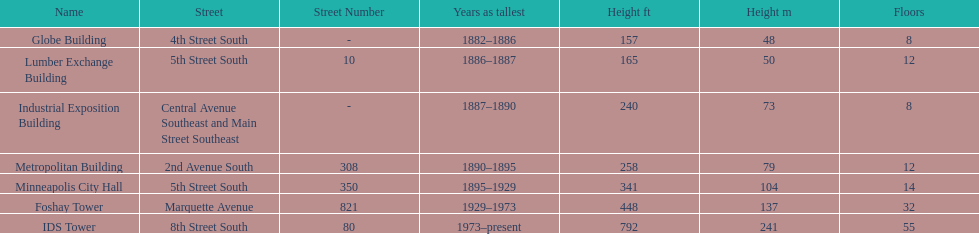After ids tower what is the second tallest building in minneapolis? Foshay Tower. 